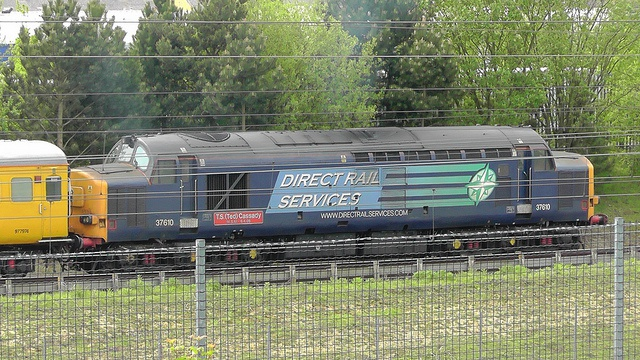Describe the objects in this image and their specific colors. I can see a train in beige, gray, darkgray, black, and lightgray tones in this image. 